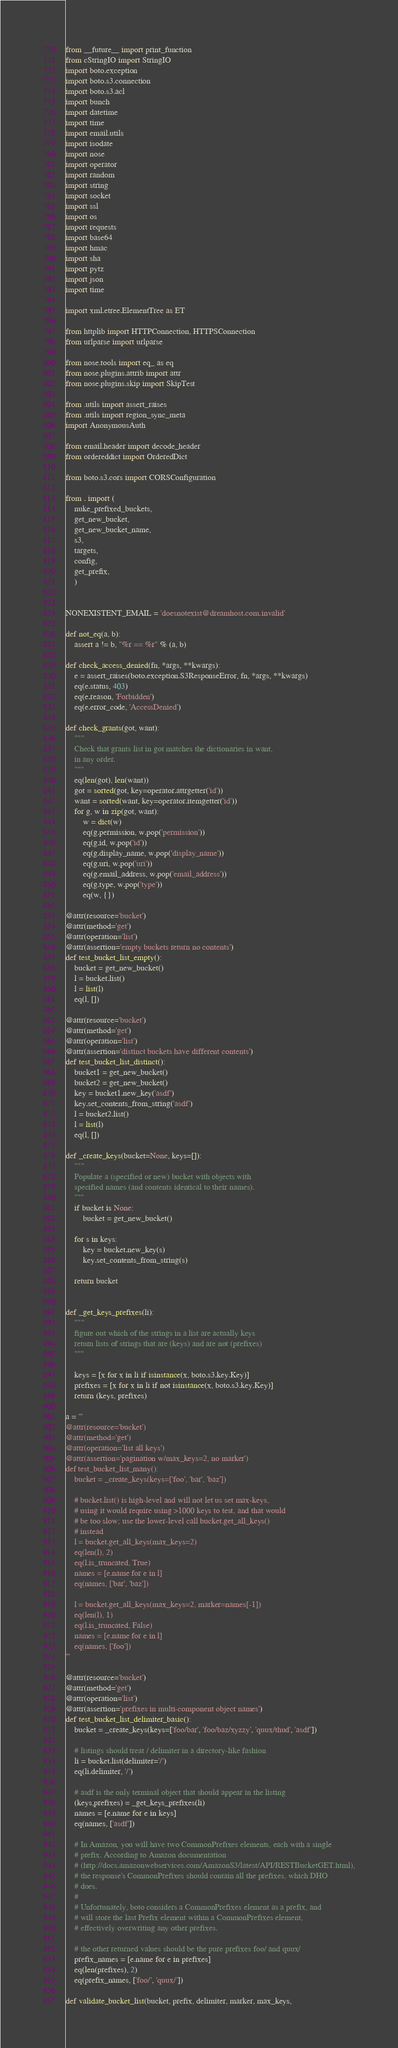Convert code to text. <code><loc_0><loc_0><loc_500><loc_500><_Python_>from __future__ import print_function
from cStringIO import StringIO
import boto.exception
import boto.s3.connection
import boto.s3.acl
import bunch
import datetime
import time
import email.utils
import isodate
import nose
import operator
import random
import string
import socket
import ssl
import os
import requests
import base64
import hmac
import sha
import pytz
import json
import time

import xml.etree.ElementTree as ET

from httplib import HTTPConnection, HTTPSConnection
from urlparse import urlparse

from nose.tools import eq_ as eq
from nose.plugins.attrib import attr
from nose.plugins.skip import SkipTest

from .utils import assert_raises
from .utils import region_sync_meta
import AnonymousAuth

from email.header import decode_header
from ordereddict import OrderedDict

from boto.s3.cors import CORSConfiguration

from . import (
    nuke_prefixed_buckets,
    get_new_bucket,
    get_new_bucket_name,
    s3,
    targets,
    config,
    get_prefix,
    )


NONEXISTENT_EMAIL = 'doesnotexist@dreamhost.com.invalid'

def not_eq(a, b):
    assert a != b, "%r == %r" % (a, b)

def check_access_denied(fn, *args, **kwargs):
    e = assert_raises(boto.exception.S3ResponseError, fn, *args, **kwargs)
    eq(e.status, 403)
    eq(e.reason, 'Forbidden')
    eq(e.error_code, 'AccessDenied')

def check_grants(got, want):
    """
    Check that grants list in got matches the dictionaries in want,
    in any order.
    """
    eq(len(got), len(want))
    got = sorted(got, key=operator.attrgetter('id'))
    want = sorted(want, key=operator.itemgetter('id'))
    for g, w in zip(got, want):
        w = dict(w)
        eq(g.permission, w.pop('permission'))
        eq(g.id, w.pop('id'))
        eq(g.display_name, w.pop('display_name'))
        eq(g.uri, w.pop('uri'))
        eq(g.email_address, w.pop('email_address'))
        eq(g.type, w.pop('type'))
        eq(w, {})

@attr(resource='bucket')
@attr(method='get')
@attr(operation='list')
@attr(assertion='empty buckets return no contents')
def test_bucket_list_empty():
    bucket = get_new_bucket()
    l = bucket.list()
    l = list(l)
    eq(l, [])

@attr(resource='bucket')
@attr(method='get')
@attr(operation='list')
@attr(assertion='distinct buckets have different contents')
def test_bucket_list_distinct():
    bucket1 = get_new_bucket()
    bucket2 = get_new_bucket()
    key = bucket1.new_key('asdf')
    key.set_contents_from_string('asdf')
    l = bucket2.list()
    l = list(l)
    eq(l, [])

def _create_keys(bucket=None, keys=[]):
    """
    Populate a (specified or new) bucket with objects with
    specified names (and contents identical to their names).
    """
    if bucket is None:
        bucket = get_new_bucket()

    for s in keys:
        key = bucket.new_key(s)
        key.set_contents_from_string(s)

    return bucket


def _get_keys_prefixes(li):
    """
    figure out which of the strings in a list are actually keys
    return lists of strings that are (keys) and are not (prefixes)
    """

    keys = [x for x in li if isinstance(x, boto.s3.key.Key)]
    prefixes = [x for x in li if not isinstance(x, boto.s3.key.Key)]
    return (keys, prefixes)

a = '''
@attr(resource='bucket')
@attr(method='get')
@attr(operation='list all keys')
@attr(assertion='pagination w/max_keys=2, no marker')
def test_bucket_list_many():
    bucket = _create_keys(keys=['foo', 'bar', 'baz'])

    # bucket.list() is high-level and will not let us set max-keys,
    # using it would require using >1000 keys to test, and that would
    # be too slow; use the lower-level call bucket.get_all_keys()
    # instead
    l = bucket.get_all_keys(max_keys=2)
    eq(len(l), 2)
    eq(l.is_truncated, True)
    names = [e.name for e in l]
    eq(names, ['bar', 'baz'])

    l = bucket.get_all_keys(max_keys=2, marker=names[-1])
    eq(len(l), 1)
    eq(l.is_truncated, False)
    names = [e.name for e in l]
    eq(names, ['foo'])
'''

@attr(resource='bucket')
@attr(method='get')
@attr(operation='list')
@attr(assertion='prefixes in multi-component object names')
def test_bucket_list_delimiter_basic():
    bucket = _create_keys(keys=['foo/bar', 'foo/baz/xyzzy', 'quux/thud', 'asdf'])

    # listings should treat / delimiter in a directory-like fashion
    li = bucket.list(delimiter='/')
    eq(li.delimiter, '/')

    # asdf is the only terminal object that should appear in the listing
    (keys,prefixes) = _get_keys_prefixes(li)
    names = [e.name for e in keys]
    eq(names, ['asdf'])

    # In Amazon, you will have two CommonPrefixes elements, each with a single
    # prefix. According to Amazon documentation
    # (http://docs.amazonwebservices.com/AmazonS3/latest/API/RESTBucketGET.html),
    # the response's CommonPrefixes should contain all the prefixes, which DHO
    # does.
    #
    # Unfortunately, boto considers a CommonPrefixes element as a prefix, and
    # will store the last Prefix element within a CommonPrefixes element,
    # effectively overwriting any other prefixes.

    # the other returned values should be the pure prefixes foo/ and quux/
    prefix_names = [e.name for e in prefixes]
    eq(len(prefixes), 2)
    eq(prefix_names, ['foo/', 'quux/'])

def validate_bucket_list(bucket, prefix, delimiter, marker, max_keys,</code> 